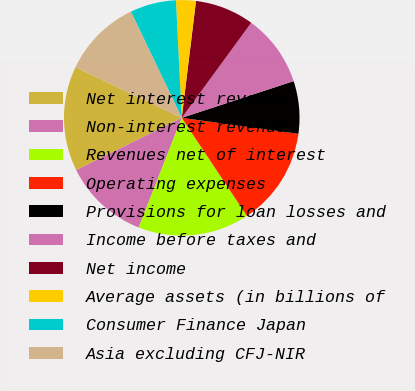<chart> <loc_0><loc_0><loc_500><loc_500><pie_chart><fcel>Net interest revenue<fcel>Non-interest revenue<fcel>Revenues net of interest<fcel>Operating expenses<fcel>Provisions for loan losses and<fcel>Income before taxes and<fcel>Net income<fcel>Average assets (in billions of<fcel>Consumer Finance Japan<fcel>Asia excluding CFJ-NIR<nl><fcel>14.4%<fcel>11.71%<fcel>15.3%<fcel>13.5%<fcel>7.21%<fcel>9.91%<fcel>8.11%<fcel>2.72%<fcel>6.32%<fcel>10.81%<nl></chart> 